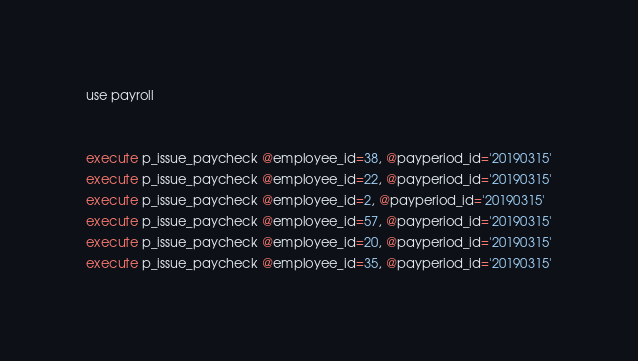Convert code to text. <code><loc_0><loc_0><loc_500><loc_500><_SQL_>use payroll


execute p_issue_paycheck @employee_id=38, @payperiod_id='20190315'
execute p_issue_paycheck @employee_id=22, @payperiod_id='20190315'
execute p_issue_paycheck @employee_id=2, @payperiod_id='20190315'
execute p_issue_paycheck @employee_id=57, @payperiod_id='20190315'
execute p_issue_paycheck @employee_id=20, @payperiod_id='20190315'
execute p_issue_paycheck @employee_id=35, @payperiod_id='20190315'</code> 